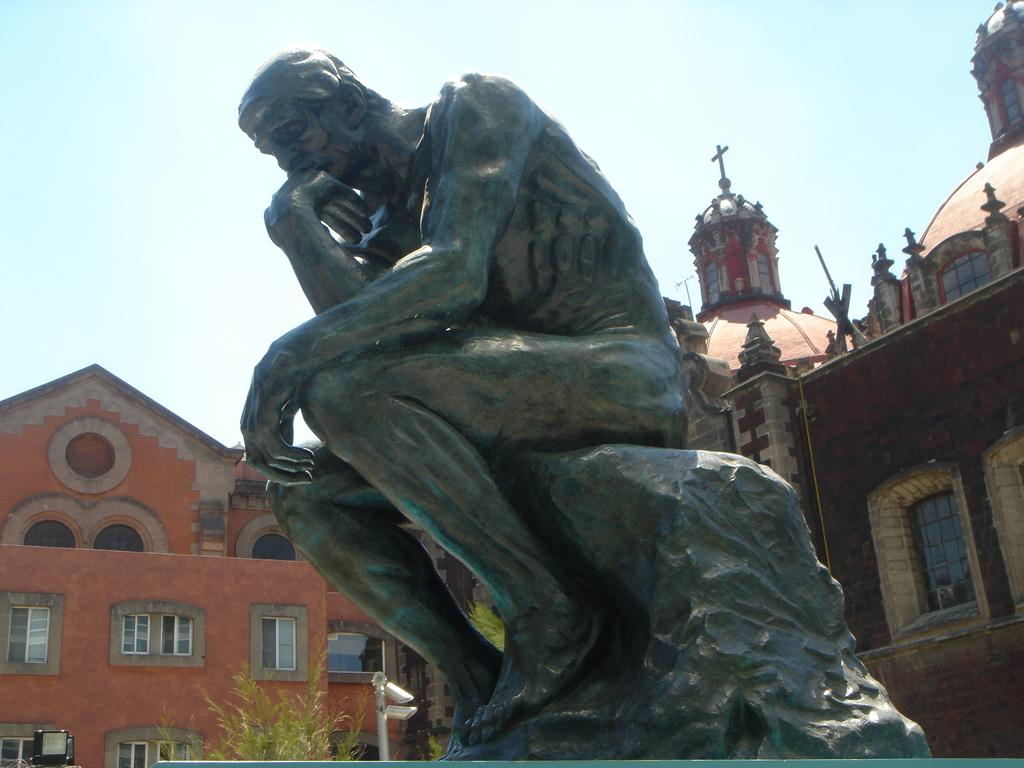What is the main subject in the center of the image? There is a statue in the center of the image. What is the color of the statue? The statue is black in color. What can be seen in the background of the image? Sky, clouds, buildings, windows, trees, and a pole are present in the background of the image. What type of guitar can be seen hanging on the door in the image? There is no guitar or door present in the image; it features a statue and various background elements. 